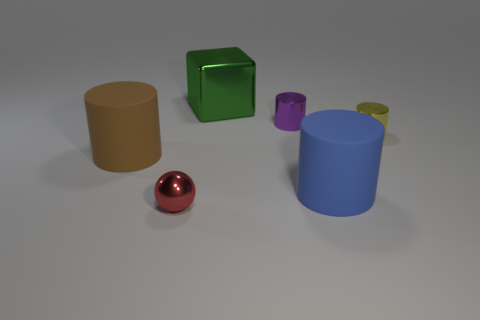Add 1 purple things. How many objects exist? 7 Subtract all balls. How many objects are left? 5 Add 3 blue rubber cylinders. How many blue rubber cylinders are left? 4 Add 6 small red metal objects. How many small red metal objects exist? 7 Subtract 1 purple cylinders. How many objects are left? 5 Subtract all big cyan rubber blocks. Subtract all yellow things. How many objects are left? 5 